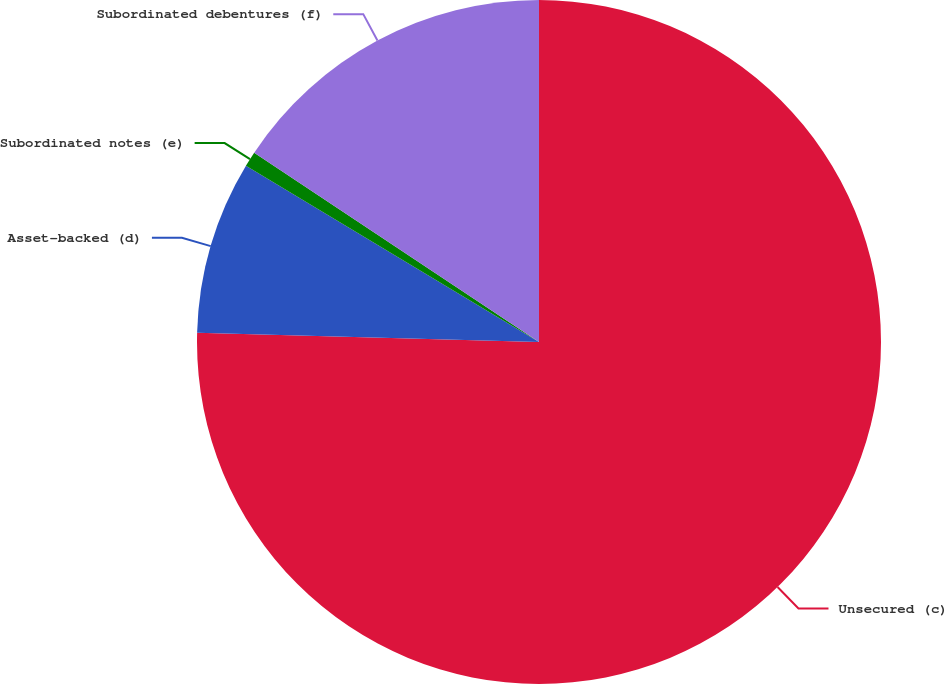Convert chart to OTSL. <chart><loc_0><loc_0><loc_500><loc_500><pie_chart><fcel>Unsecured (c)<fcel>Asset-backed (d)<fcel>Subordinated notes (e)<fcel>Subordinated debentures (f)<nl><fcel>75.42%<fcel>8.19%<fcel>0.72%<fcel>15.66%<nl></chart> 